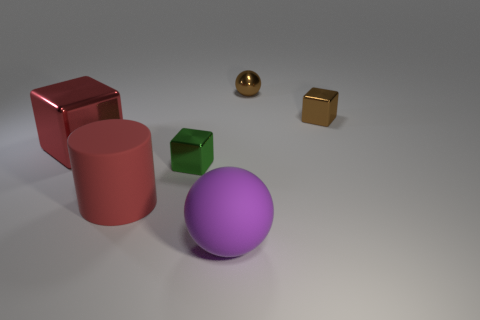Is there anything else that is made of the same material as the purple object? Yes, the golden sphere on the right appears to be made of a similar smooth and reflective material as the purple sphere. 